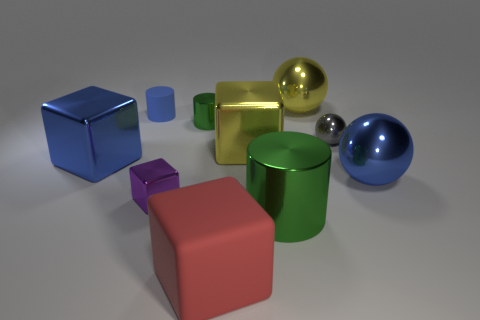Subtract all big metallic balls. How many balls are left? 1 Subtract 1 spheres. How many spheres are left? 2 Subtract all green cubes. How many green cylinders are left? 2 Subtract all yellow spheres. How many spheres are left? 2 Subtract all cylinders. How many objects are left? 7 Add 5 tiny blue cylinders. How many tiny blue cylinders exist? 6 Subtract 1 green cylinders. How many objects are left? 9 Subtract all red cylinders. Subtract all red cubes. How many cylinders are left? 3 Subtract all tiny cyan rubber cylinders. Subtract all purple metallic things. How many objects are left? 9 Add 9 rubber cylinders. How many rubber cylinders are left? 10 